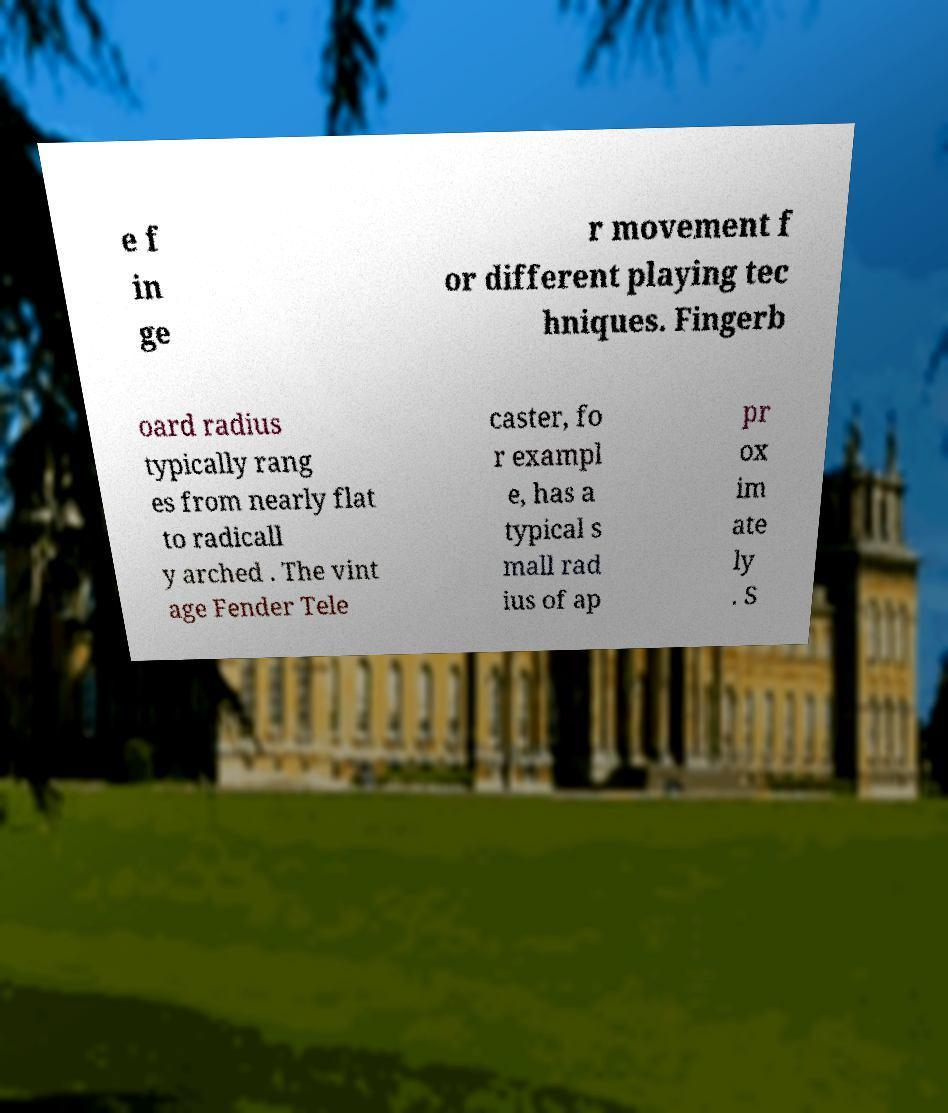Can you accurately transcribe the text from the provided image for me? e f in ge r movement f or different playing tec hniques. Fingerb oard radius typically rang es from nearly flat to radicall y arched . The vint age Fender Tele caster, fo r exampl e, has a typical s mall rad ius of ap pr ox im ate ly . S 